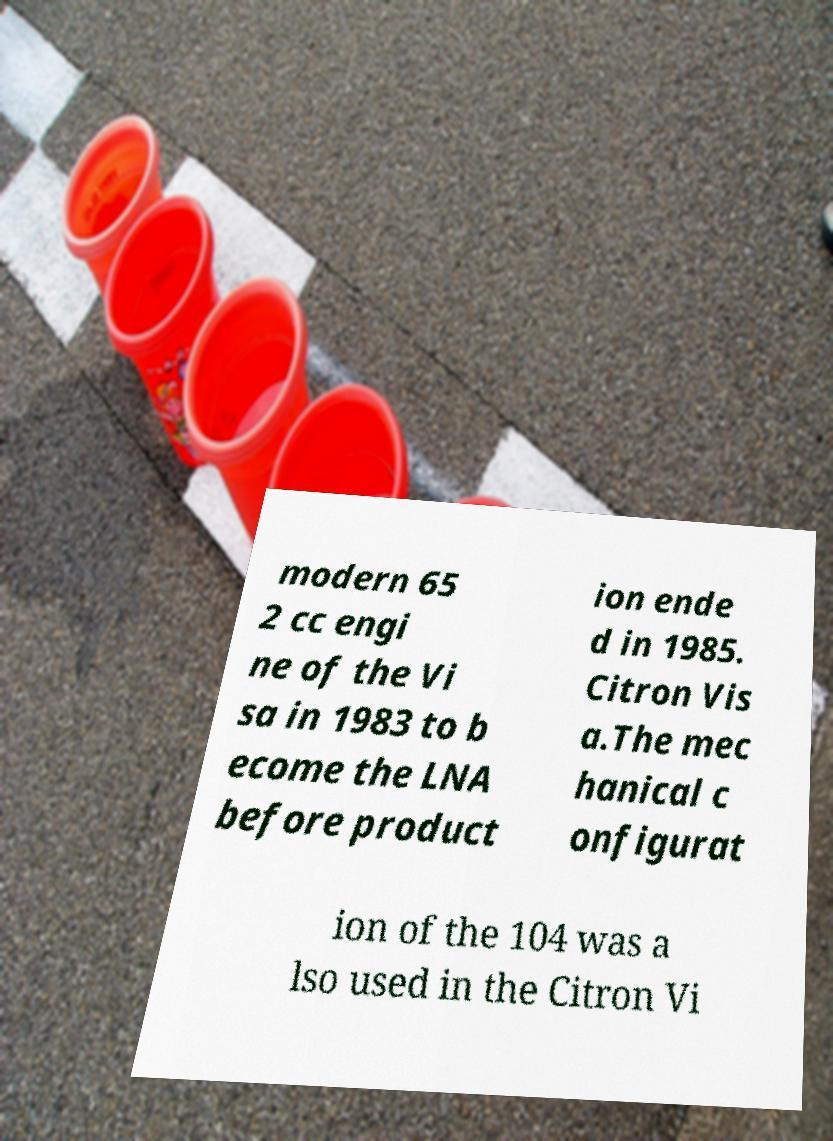I need the written content from this picture converted into text. Can you do that? modern 65 2 cc engi ne of the Vi sa in 1983 to b ecome the LNA before product ion ende d in 1985. Citron Vis a.The mec hanical c onfigurat ion of the 104 was a lso used in the Citron Vi 